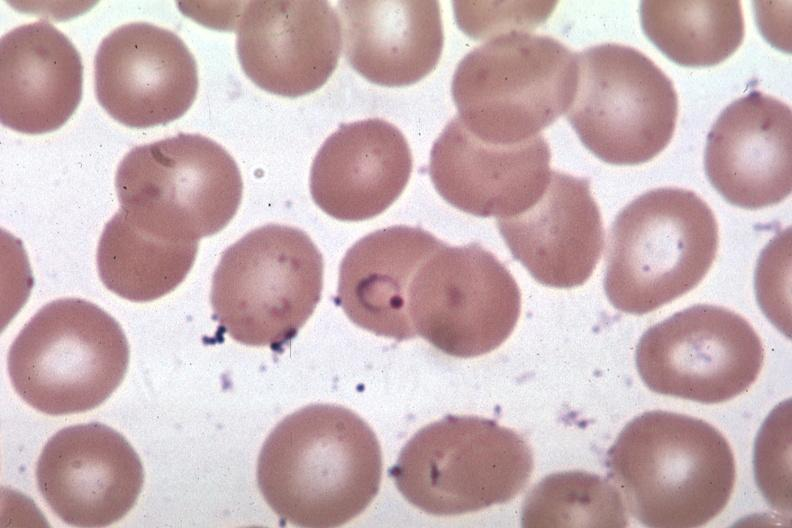what is present?
Answer the question using a single word or phrase. Blood 